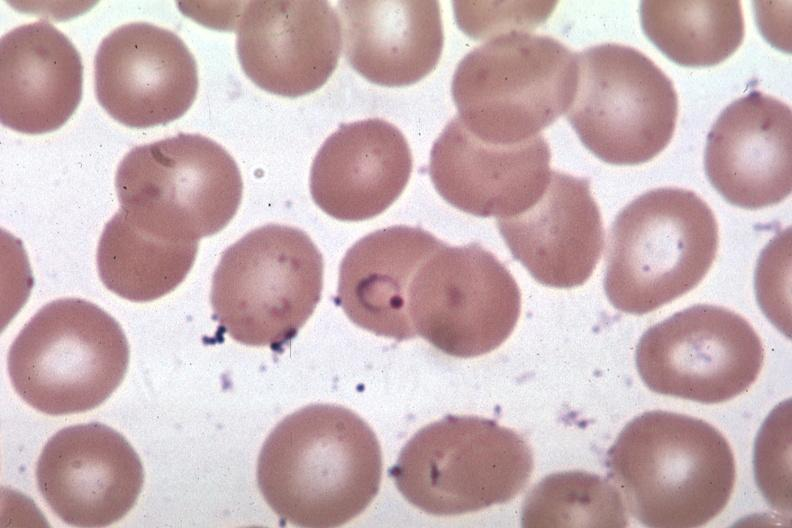what is present?
Answer the question using a single word or phrase. Blood 